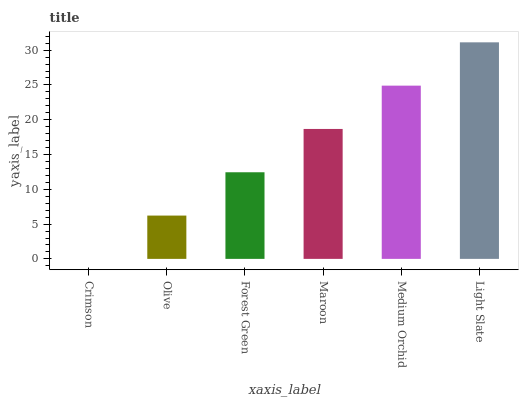Is Crimson the minimum?
Answer yes or no. Yes. Is Light Slate the maximum?
Answer yes or no. Yes. Is Olive the minimum?
Answer yes or no. No. Is Olive the maximum?
Answer yes or no. No. Is Olive greater than Crimson?
Answer yes or no. Yes. Is Crimson less than Olive?
Answer yes or no. Yes. Is Crimson greater than Olive?
Answer yes or no. No. Is Olive less than Crimson?
Answer yes or no. No. Is Maroon the high median?
Answer yes or no. Yes. Is Forest Green the low median?
Answer yes or no. Yes. Is Medium Orchid the high median?
Answer yes or no. No. Is Light Slate the low median?
Answer yes or no. No. 